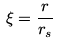<formula> <loc_0><loc_0><loc_500><loc_500>\xi = \frac { r } { r _ { s } }</formula> 